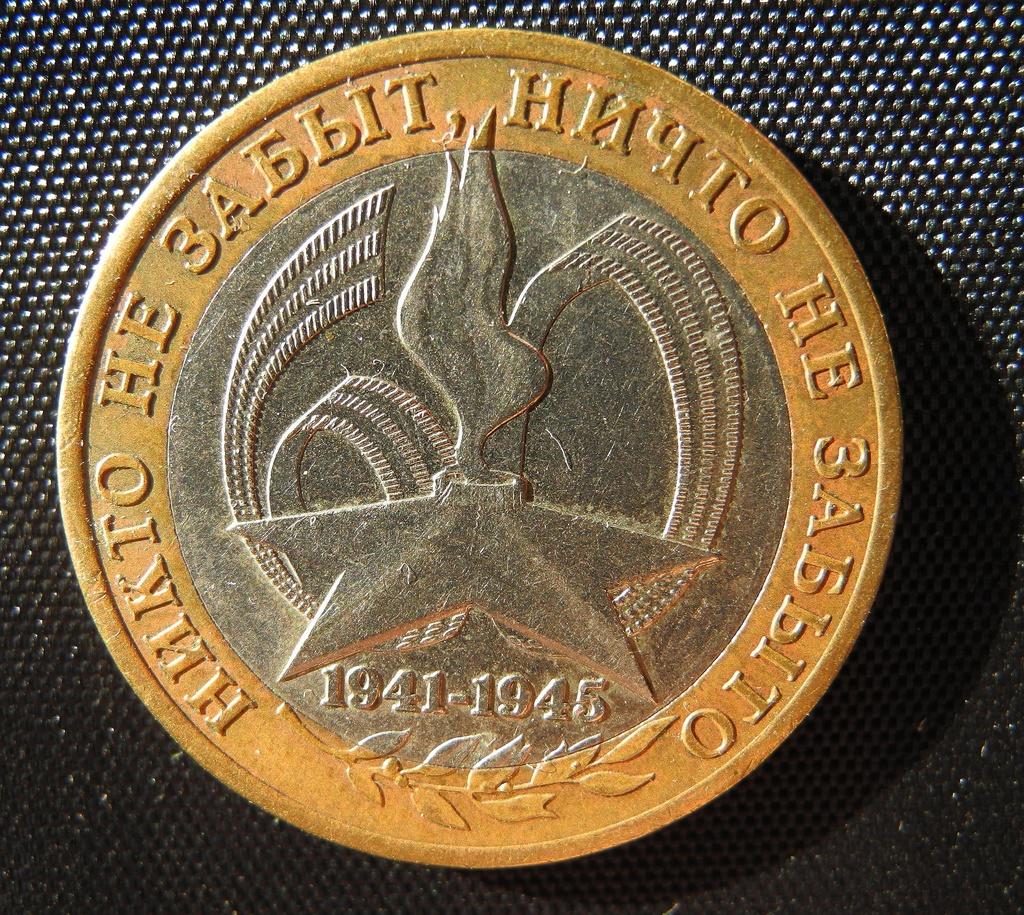What years are listed on the coin?
Offer a terse response. 1941-1945. 